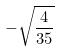Convert formula to latex. <formula><loc_0><loc_0><loc_500><loc_500>- \sqrt { \frac { 4 } { 3 5 } }</formula> 